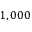<formula> <loc_0><loc_0><loc_500><loc_500>1 , 0 0 0</formula> 